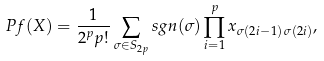<formula> <loc_0><loc_0><loc_500><loc_500>P f ( X ) = \frac { 1 } { 2 ^ { p } p ! } \sum _ { \sigma \in S _ { 2 p } } s g n ( \sigma ) \prod _ { i = 1 } ^ { p } x _ { \sigma ( 2 i - 1 ) \, \sigma ( 2 i ) } ,</formula> 